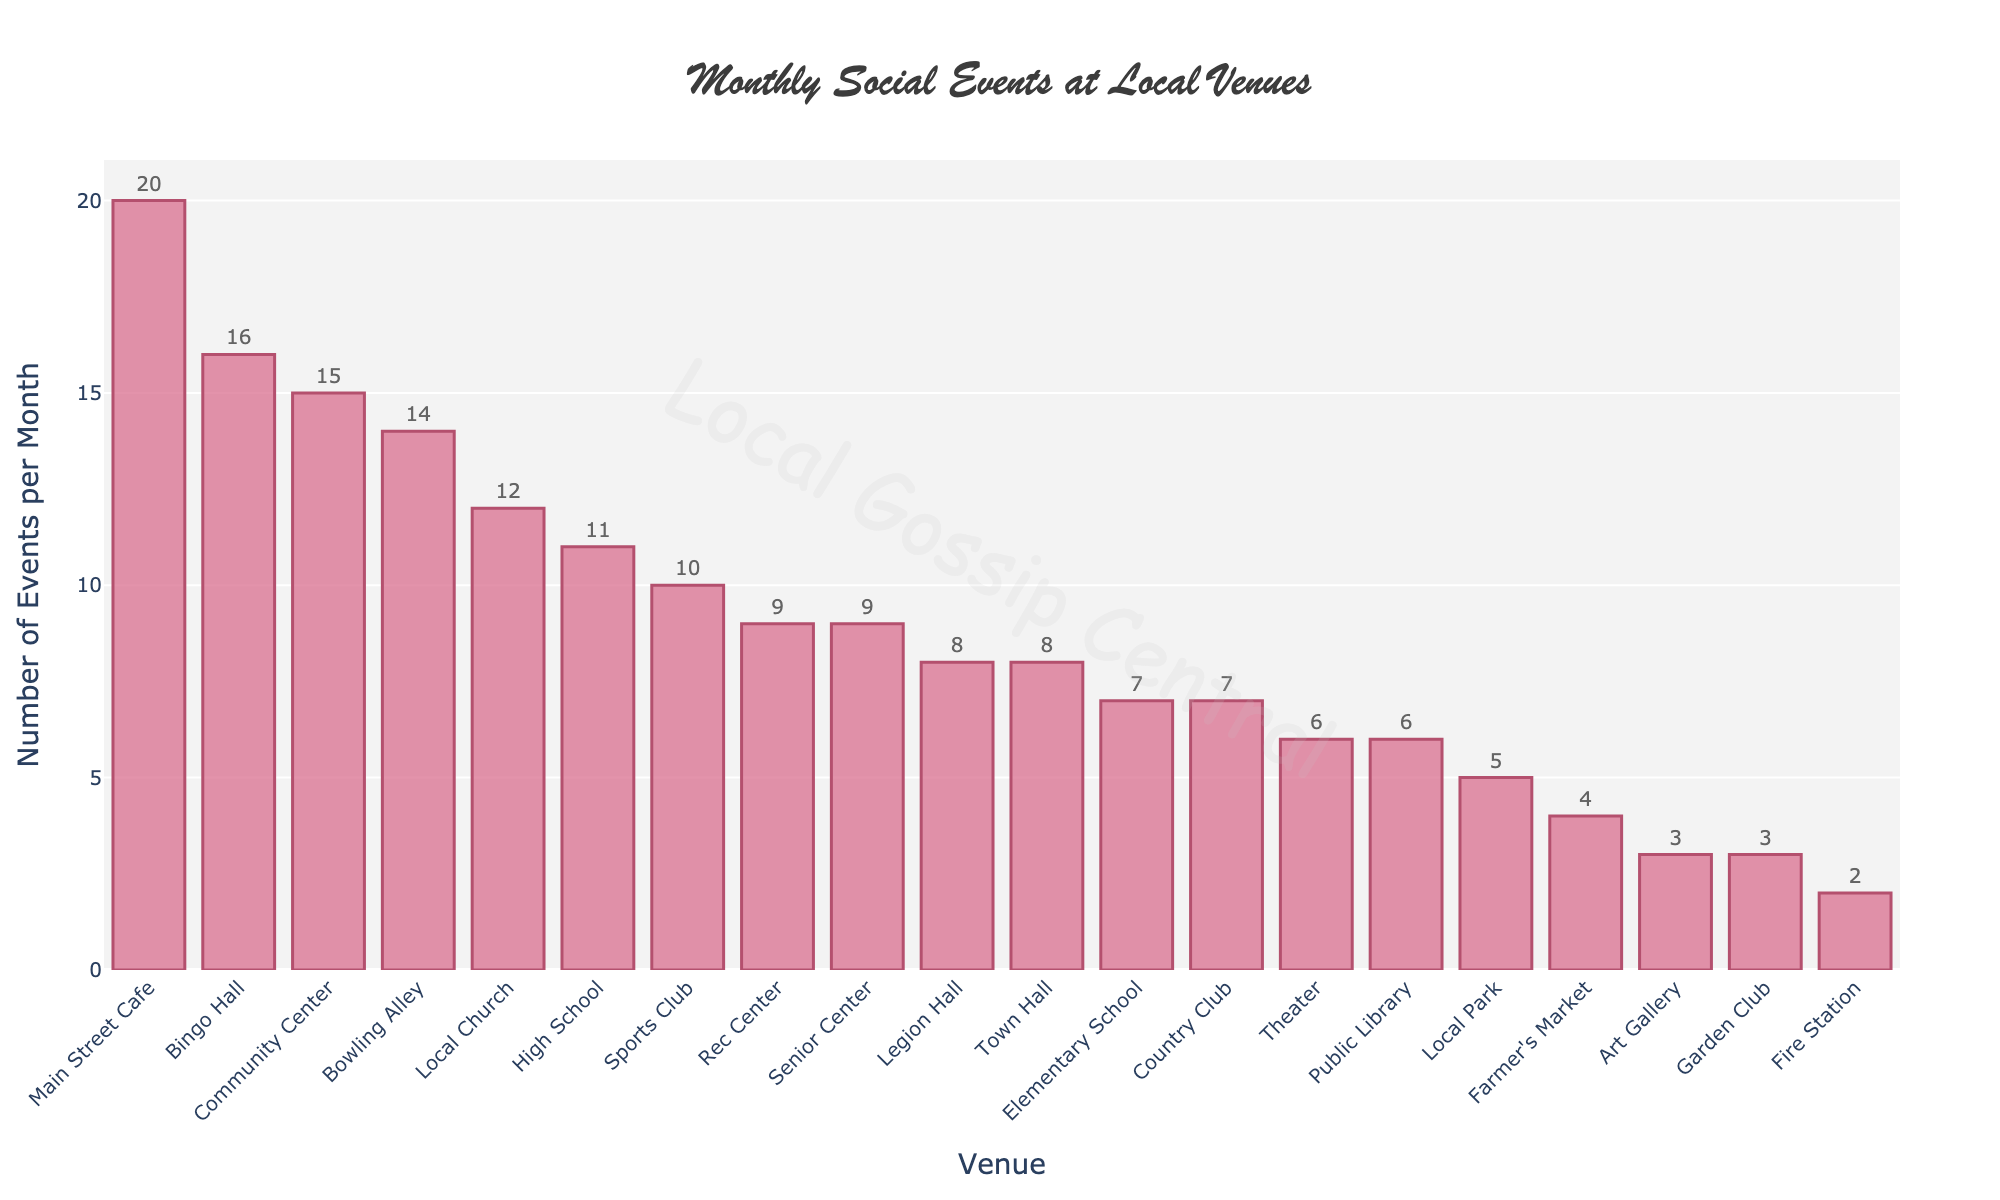Which venue has the highest number of events per month? The bar chart shows that Main Street Cafe has the tallest bar, indicating it has the highest number of events per month.
Answer: Main Street Cafe How many events do the Town Hall and Local Church have combined each month? The Town Hall has 8 events and the Local Church has 12 events per month. Summing these gives 8 + 12.
Answer: 20 Which venue has fewer events per month: the Public Library or the High School? By comparing the heights of the bars, the Public Library has fewer events (6) than the High School (11).
Answer: Public Library What is the difference in the number of events per month between the Sports Club and the Senior Center? The Sports Club has 10 events and the Senior Center has 9 events per month. The difference is 10 - 9.
Answer: 1 Which venues have exactly 3 events per month? According to the bar chart, the Art Gallery and the Garden Club each have 3 events per month.
Answer: Art Gallery, Garden Club Are there more events at the Elementary School or the Theater each month? Comparing the heights of the bars, the Elementary School has 7 events and the Theater has 6 events each month. 7 is more than 6.
Answer: Elementary School What is the total number of events per month across the Bowling Alley, Bingo Hall, and Local Park? The Bowling Alley has 14 events, the Bingo Hall has 16 events, and the Local Park has 5 events. The total is 14 + 16 + 5.
Answer: 35 Which venue hosts exactly half as many events as the Community Center each month? The Community Center has 15 events per month. Half of 15 is 7.5, but since we are looking for an exact match, the Country Club and Elementary School (each with 7 events) are the closest venues.
Answer: Country Club, Elementary School How many more events does the Main Street Cafe have compared to the Theater? The Main Street Cafe has 20 events and the Theater has 6 events. The difference is 20 - 6.
Answer: 14 